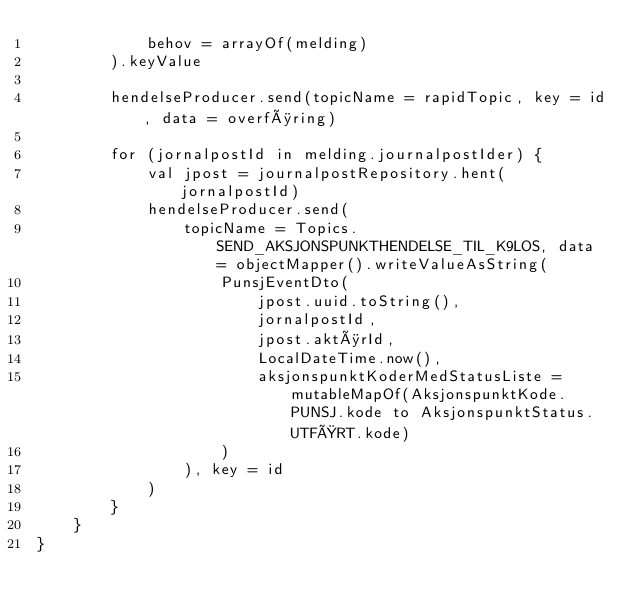Convert code to text. <code><loc_0><loc_0><loc_500><loc_500><_Kotlin_>            behov = arrayOf(melding)
        ).keyValue

        hendelseProducer.send(topicName = rapidTopic, key = id, data = overføring)

        for (jornalpostId in melding.journalpostIder) {
            val jpost = journalpostRepository.hent(jornalpostId)
            hendelseProducer.send(
                topicName = Topics.SEND_AKSJONSPUNKTHENDELSE_TIL_K9LOS, data = objectMapper().writeValueAsString(
                    PunsjEventDto(
                        jpost.uuid.toString(),
                        jornalpostId,
                        jpost.aktørId,
                        LocalDateTime.now(),
                        aksjonspunktKoderMedStatusListe = mutableMapOf(AksjonspunktKode.PUNSJ.kode to AksjonspunktStatus.UTFØRT.kode)
                    )
                ), key = id
            )
        }
    }
}
</code> 